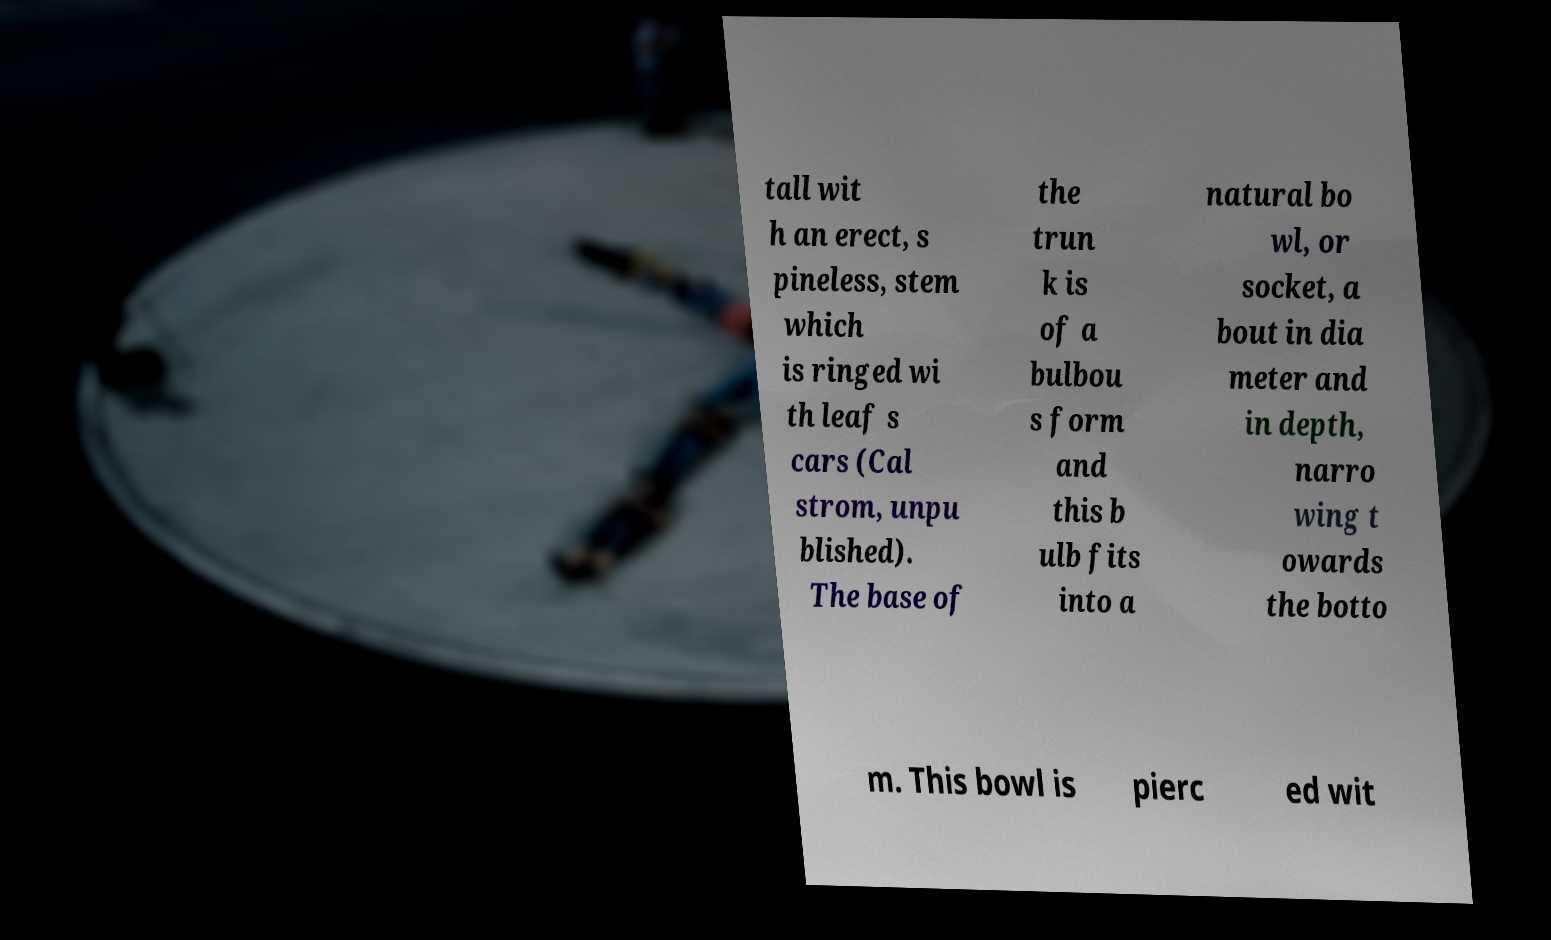Please identify and transcribe the text found in this image. tall wit h an erect, s pineless, stem which is ringed wi th leaf s cars (Cal strom, unpu blished). The base of the trun k is of a bulbou s form and this b ulb fits into a natural bo wl, or socket, a bout in dia meter and in depth, narro wing t owards the botto m. This bowl is pierc ed wit 